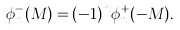<formula> <loc_0><loc_0><loc_500><loc_500>\phi _ { n } ^ { - } ( M ) = ( - 1 ) ^ { n } \phi ^ { + } _ { n } ( - M ) .</formula> 